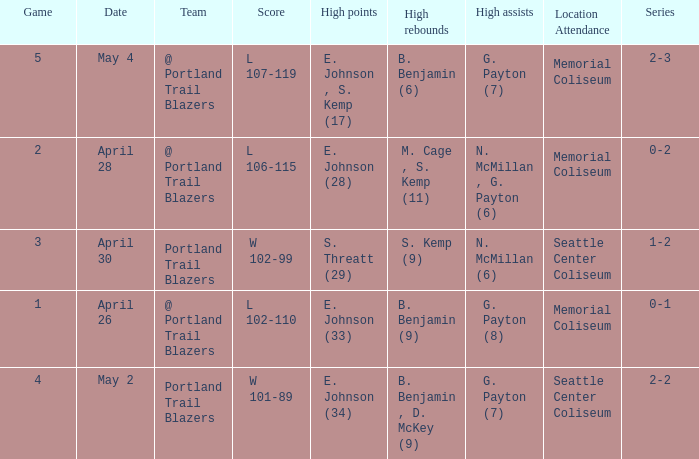Considering a 0-2 series, what are the peak points? E. Johnson (28). 